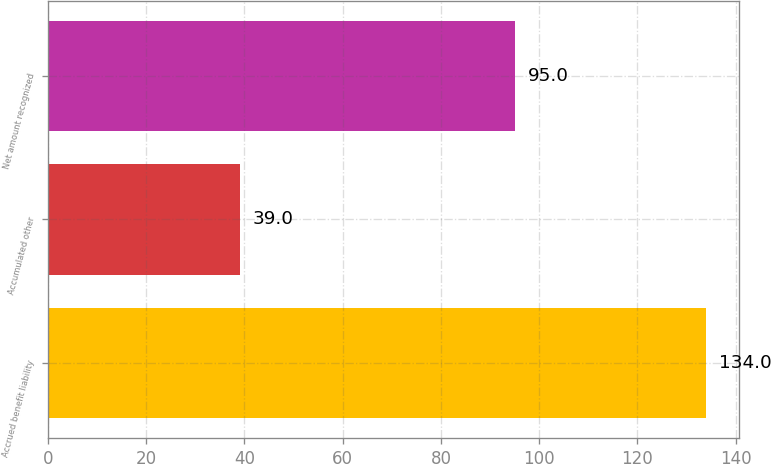Convert chart. <chart><loc_0><loc_0><loc_500><loc_500><bar_chart><fcel>Accrued benefit liability<fcel>Accumulated other<fcel>Net amount recognized<nl><fcel>134<fcel>39<fcel>95<nl></chart> 